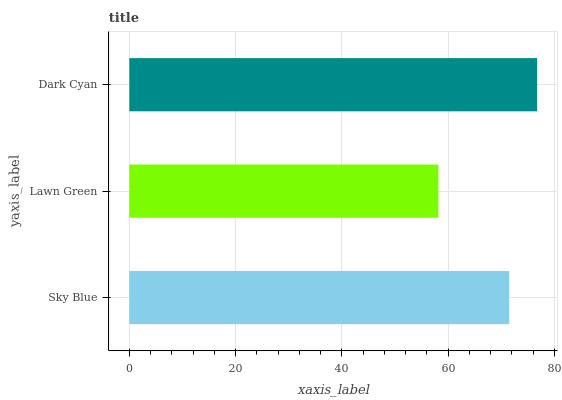Is Lawn Green the minimum?
Answer yes or no. Yes. Is Dark Cyan the maximum?
Answer yes or no. Yes. Is Dark Cyan the minimum?
Answer yes or no. No. Is Lawn Green the maximum?
Answer yes or no. No. Is Dark Cyan greater than Lawn Green?
Answer yes or no. Yes. Is Lawn Green less than Dark Cyan?
Answer yes or no. Yes. Is Lawn Green greater than Dark Cyan?
Answer yes or no. No. Is Dark Cyan less than Lawn Green?
Answer yes or no. No. Is Sky Blue the high median?
Answer yes or no. Yes. Is Sky Blue the low median?
Answer yes or no. Yes. Is Lawn Green the high median?
Answer yes or no. No. Is Dark Cyan the low median?
Answer yes or no. No. 